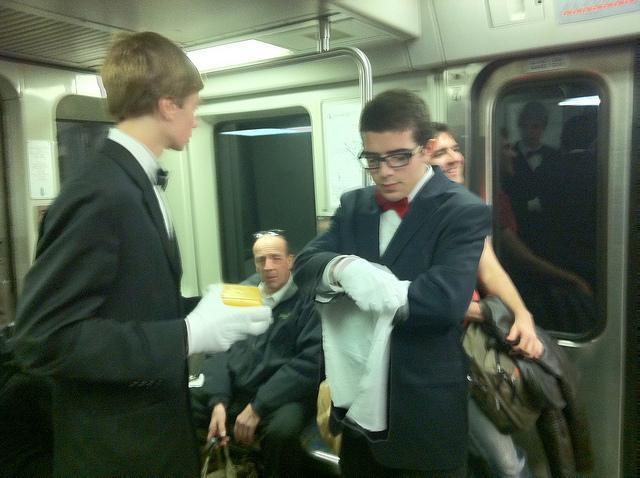How many people are there?
Give a very brief answer. 6. How many birds have their wings spread?
Give a very brief answer. 0. 